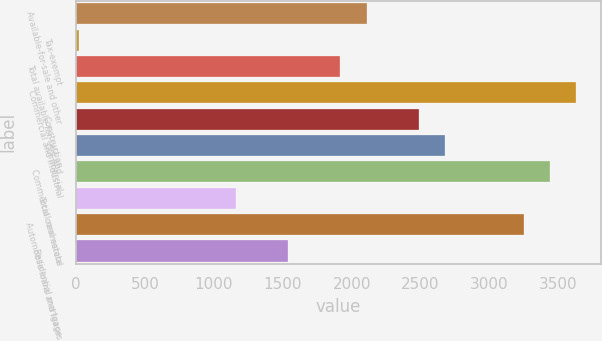Convert chart to OTSL. <chart><loc_0><loc_0><loc_500><loc_500><bar_chart><fcel>Available-for-sale and other<fcel>Tax-exempt<fcel>Total available-for-sale and<fcel>Commercial and industrial<fcel>Construction<fcel>Commercial<fcel>Commercial real estate<fcel>Total commercial<fcel>Automobile loans and leases<fcel>Residential mortgage<nl><fcel>2108.1<fcel>17<fcel>1918<fcel>3628.9<fcel>2488.3<fcel>2678.4<fcel>3438.8<fcel>1157.6<fcel>3248.7<fcel>1537.8<nl></chart> 